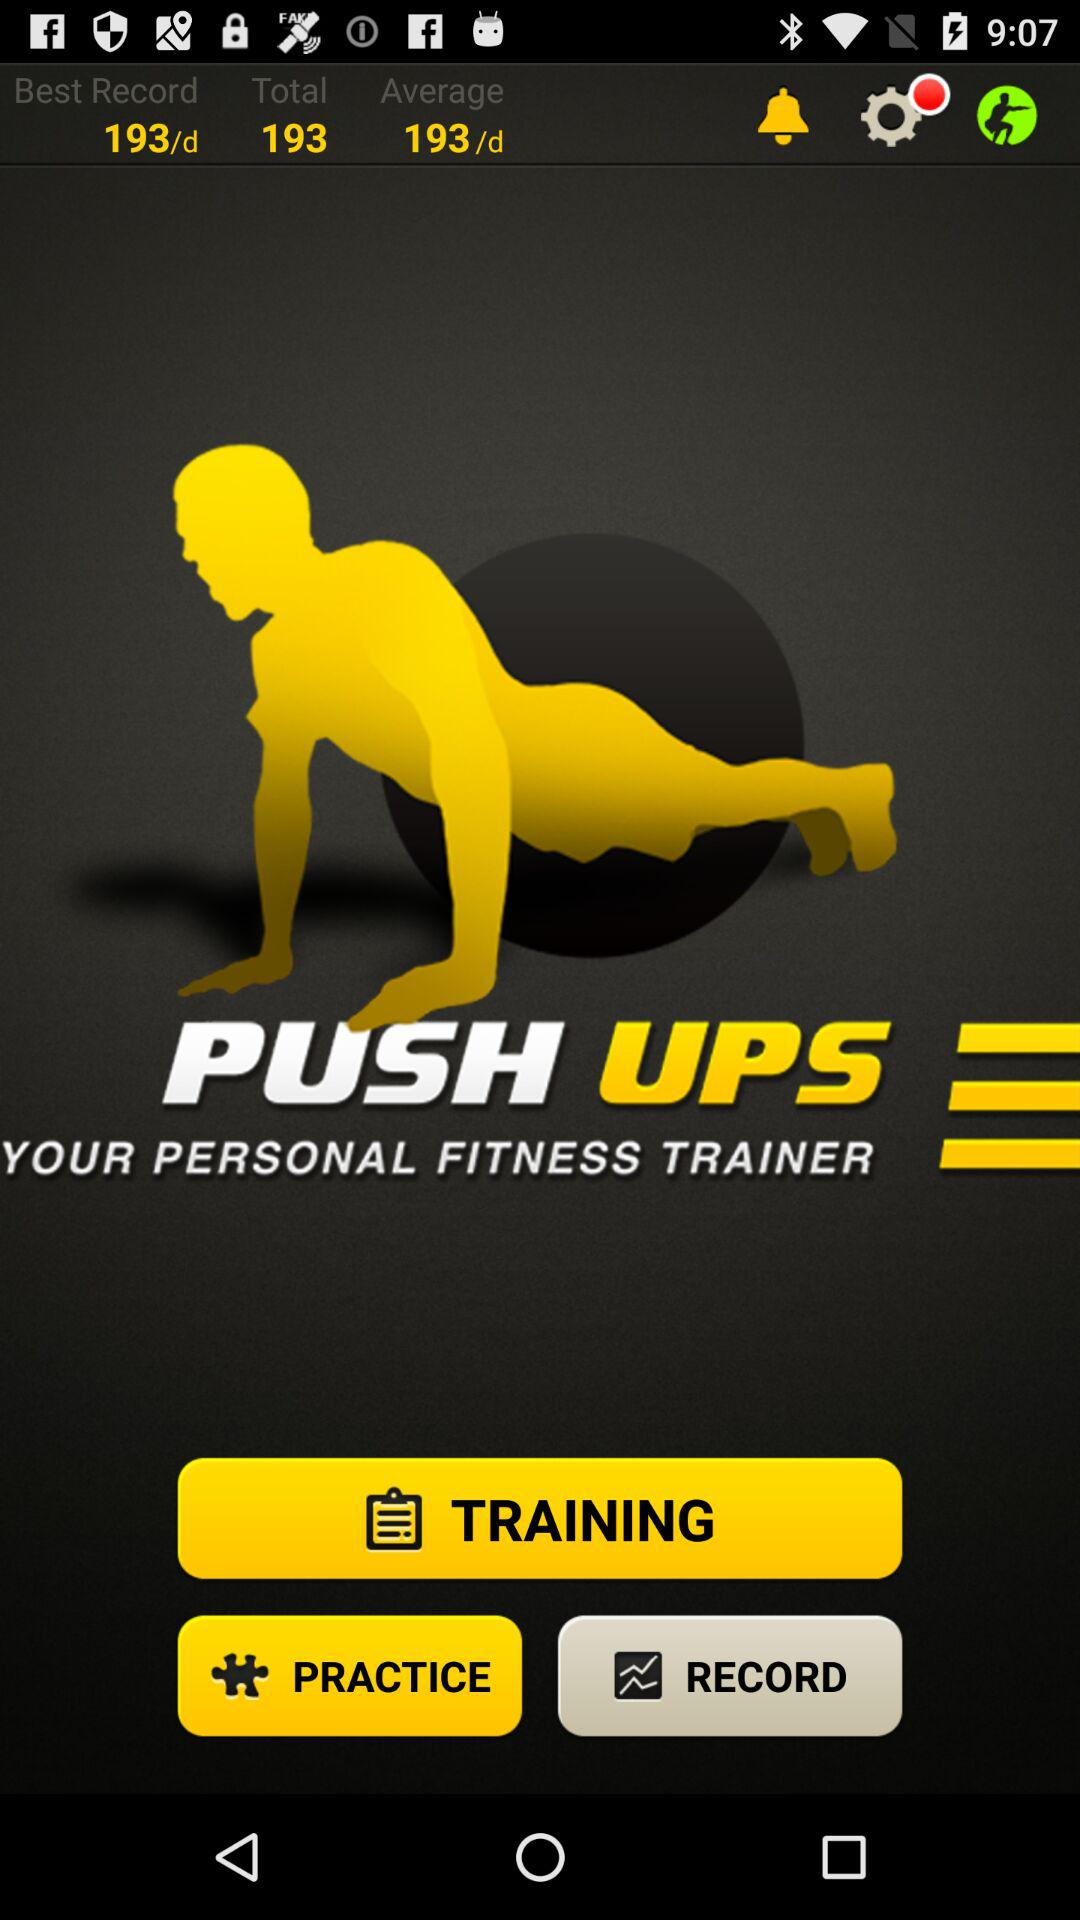What is the best record? The best record is 193 per day. 